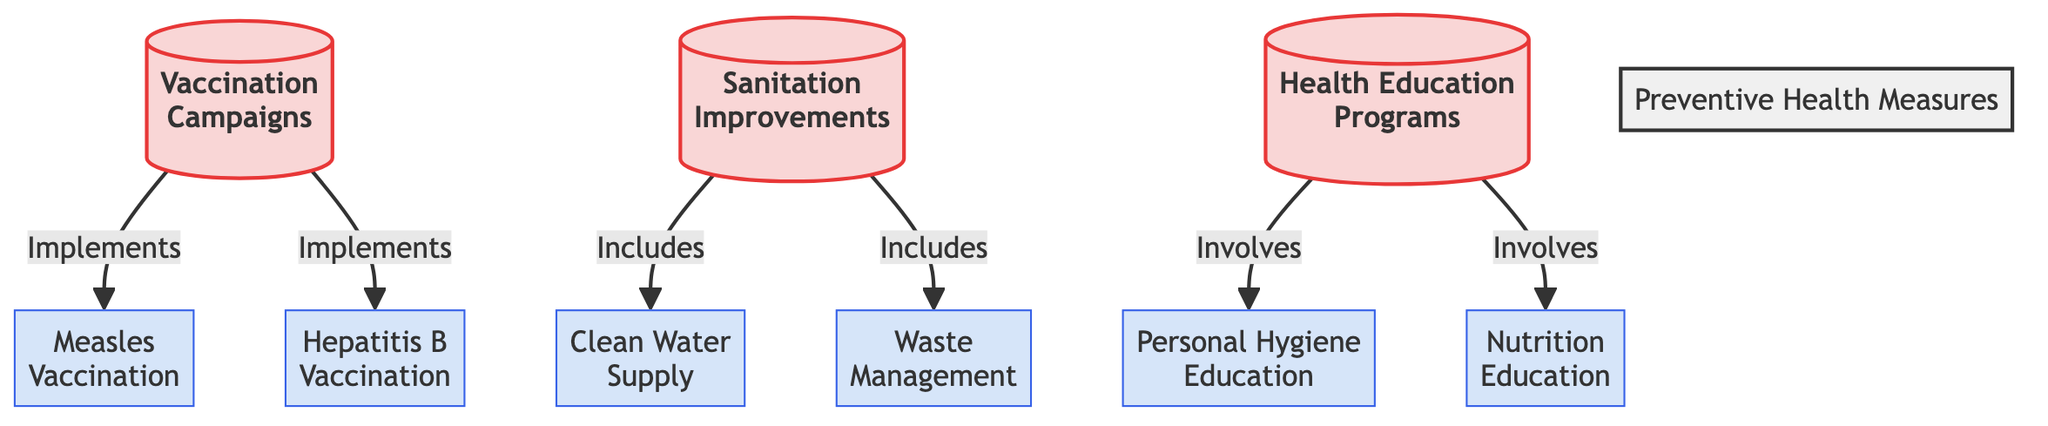What are the three main preventive health measures depicted? The diagram shows three main preventive health measures: Vaccination Campaigns, Sanitation Improvements, and Health Education Programs. Each of these is a primary node in the diagram that connects to various sub-nodes with specific implementations.
Answer: Vaccination Campaigns, Sanitation Improvements, Health Education Programs How many vaccination types are included in the diagram? There are two specific vaccination types depicted in the diagram: Measles Vaccination and Hepatitis B Vaccination. Both are sub-nodes linked to the Vaccination Campaigns node.
Answer: 2 What does sanitation improvements include? Sanitation Improvements include Clean Water Supply and Waste Management. The diagram clearly illustrates that these two sub-nodes stem from the Sanitation Improvements node, indicating their importance in this preventive measure.
Answer: Clean Water Supply, Waste Management Which preventive health measure involves personal hygiene? The Health Education Programs node involves Personal Hygiene Education, as shown in the diagram where this sub-node is directly linked to the Health Education Programs node.
Answer: Health Education Programs What is the connection between health education programs and nutrition? Health Education Programs involves Nutrition Education as one of its aspects. This indicates that part of the focus of health education is on promoting better nutritional practices, as depicted in the connections shown in the diagram.
Answer: Involves Nutrition Education 